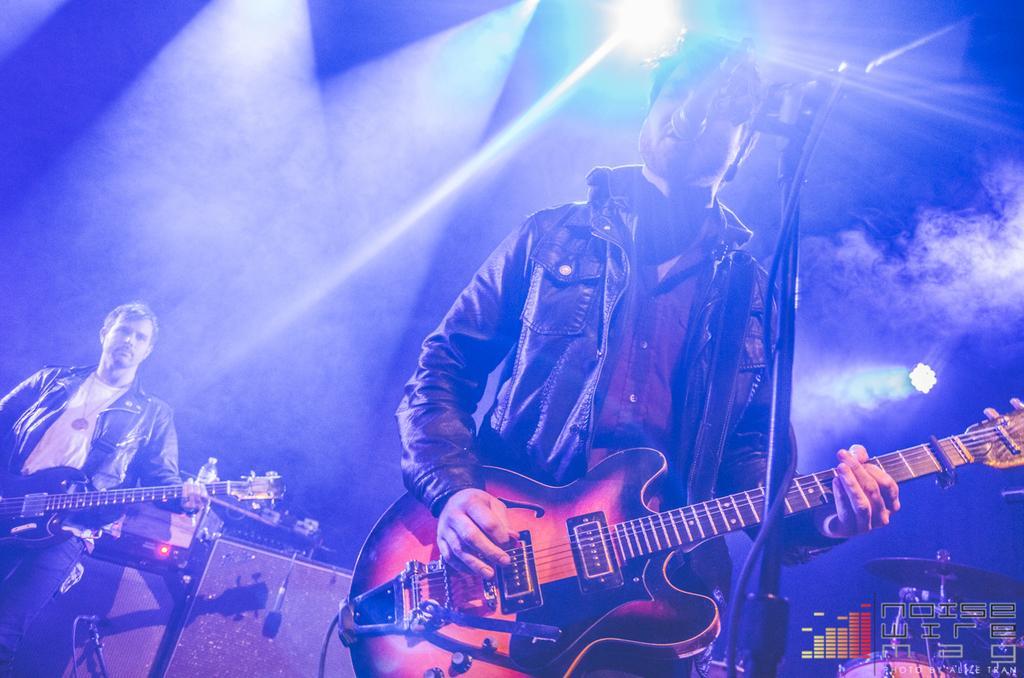How would you summarize this image in a sentence or two? In this picture we can see two men holding guitars in their hands and playing it and one is singing on mic and in background we can see drums, mics, bottle, speakers, light, smoke. 